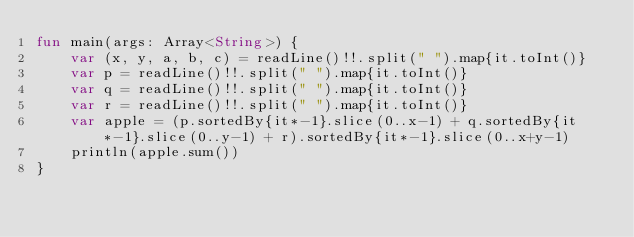Convert code to text. <code><loc_0><loc_0><loc_500><loc_500><_Kotlin_>fun main(args: Array<String>) {
    var (x, y, a, b, c) = readLine()!!.split(" ").map{it.toInt()}
    var p = readLine()!!.split(" ").map{it.toInt()}
    var q = readLine()!!.split(" ").map{it.toInt()}
    var r = readLine()!!.split(" ").map{it.toInt()}
    var apple = (p.sortedBy{it*-1}.slice(0..x-1) + q.sortedBy{it*-1}.slice(0..y-1) + r).sortedBy{it*-1}.slice(0..x+y-1)
    println(apple.sum())
}
</code> 